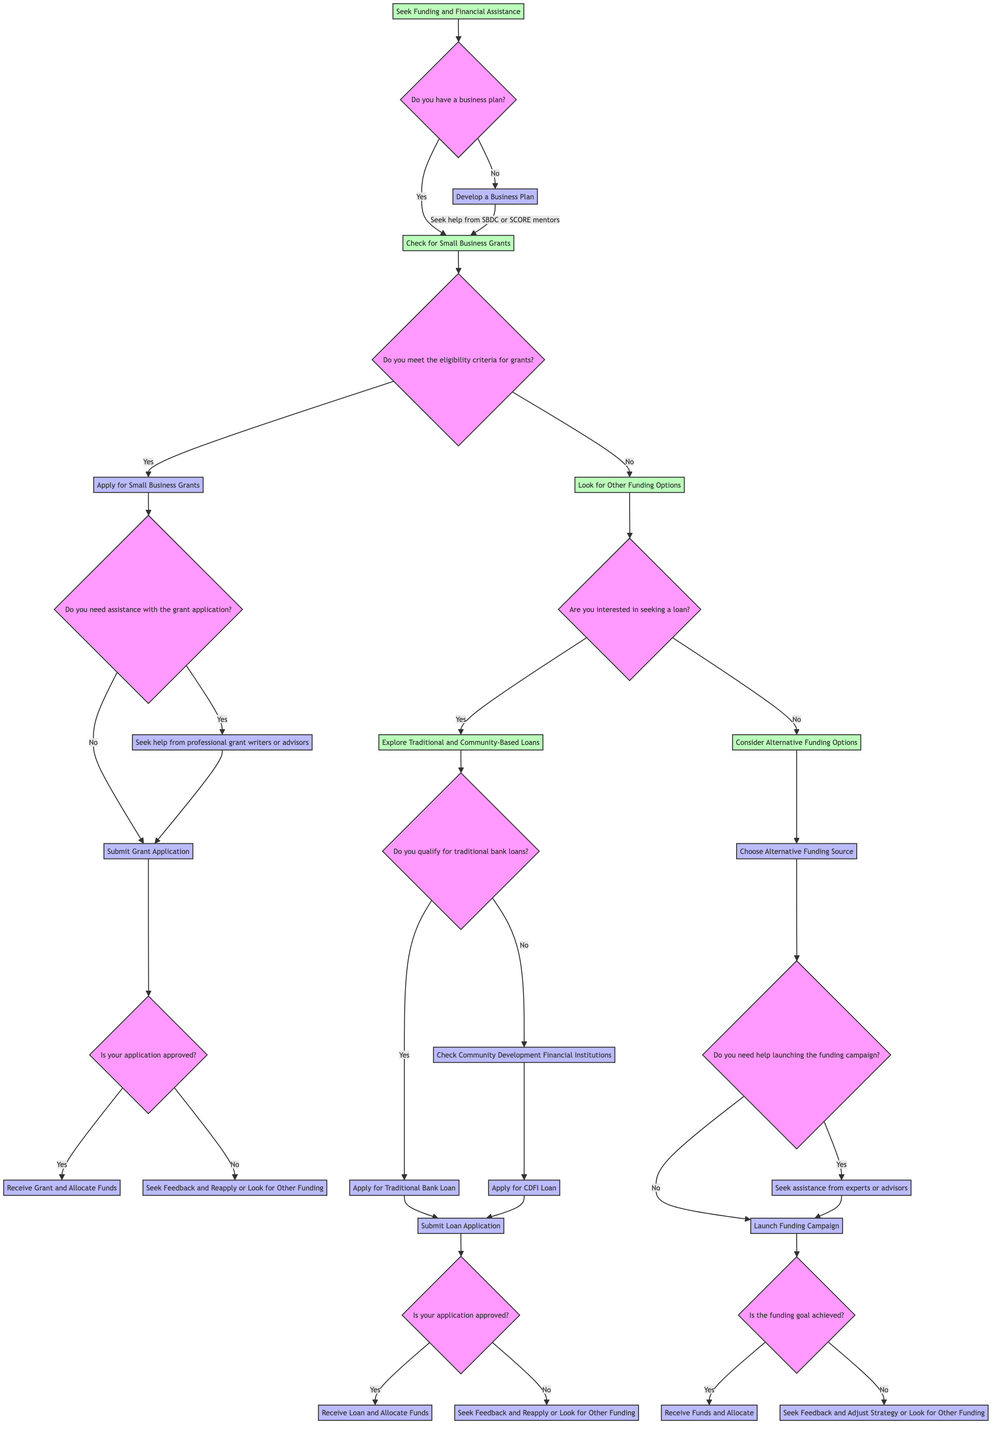What is the first question in the diagram? The diagram begins with the question: "Do you have a business plan?" This can be found directly at the starting point of the decision tree.
Answer: Do you have a business plan? How many options are available after "Check for Small Business Grants"? After "Check for Small Business Grants", there are 2 options based on the answer to the question regarding eligibility criteria: "Apply for Small Business Grants" and "Look for Other Funding Options". This can be traced from the corresponding node that splits into two pathways.
Answer: 2 What is the next step after "Submit Grant Application"? Following "Submit Grant Application", the next step specified in the diagram is "Await Results of Grant Application", which is the subsequent node in the flow after submitting the application.
Answer: Await Results of Grant Application What happens if the grant application is not approved? If the grant application is not approved, the diagram indicates that the next step is to "Seek Feedback and Reapply or Look for Other Funding". This can be derived by following the yes/no pathway from the "Await Results of Grant Application" node.
Answer: Seek Feedback and Reapply or Look for Other Funding How does the decision flow change if the answer is "No" to the eligibility criteria for grants? When the answer is "No" to the eligibility criteria for grants, the flow leads to "Look for Other Funding Options". This is a branch from the node "Check for Small Business Grants" that indicates the alternative pathway based on a negative response.
Answer: Look for Other Funding Options What types of loans are explored if seeking a loan? If the option "Yes" is selected for seeking a loan, the option "Explore Traditional and Community-Based Loans" appears, indicating that these types of loans are the focus of exploration. This follows the pathway that stems from "Look for Other Funding Options".
Answer: Explore Traditional and Community-Based Loans What step follows "Choose Alternative Funding Source" if help is needed? After "Choose Alternative Funding Source", if the answer is "Yes" regarding the need for help launching the funding campaign, the next step is to "Seek assistance from experts or advisors". This is derived from the decision path that follows the question about help.
Answer: Seek assistance from experts or advisors What question is asked after awaiting the results of the loan application? After "Await Results of Loan Application", the question asked is "Is your application approved?" This leads into a decision node that determines the next steps based on whether the application is approved or not.
Answer: Is your application approved? What can be done if the funding goal is not achieved? If the funding goal is not achieved as indicated by "Await Results of Funding Campaign", the next action is to "Seek Feedback and Adjust Strategy or Look for Other Funding". This indicates the alternatives presented following a negative outcome from the funding campaign.
Answer: Seek Feedback and Adjust Strategy or Look for Other Funding 